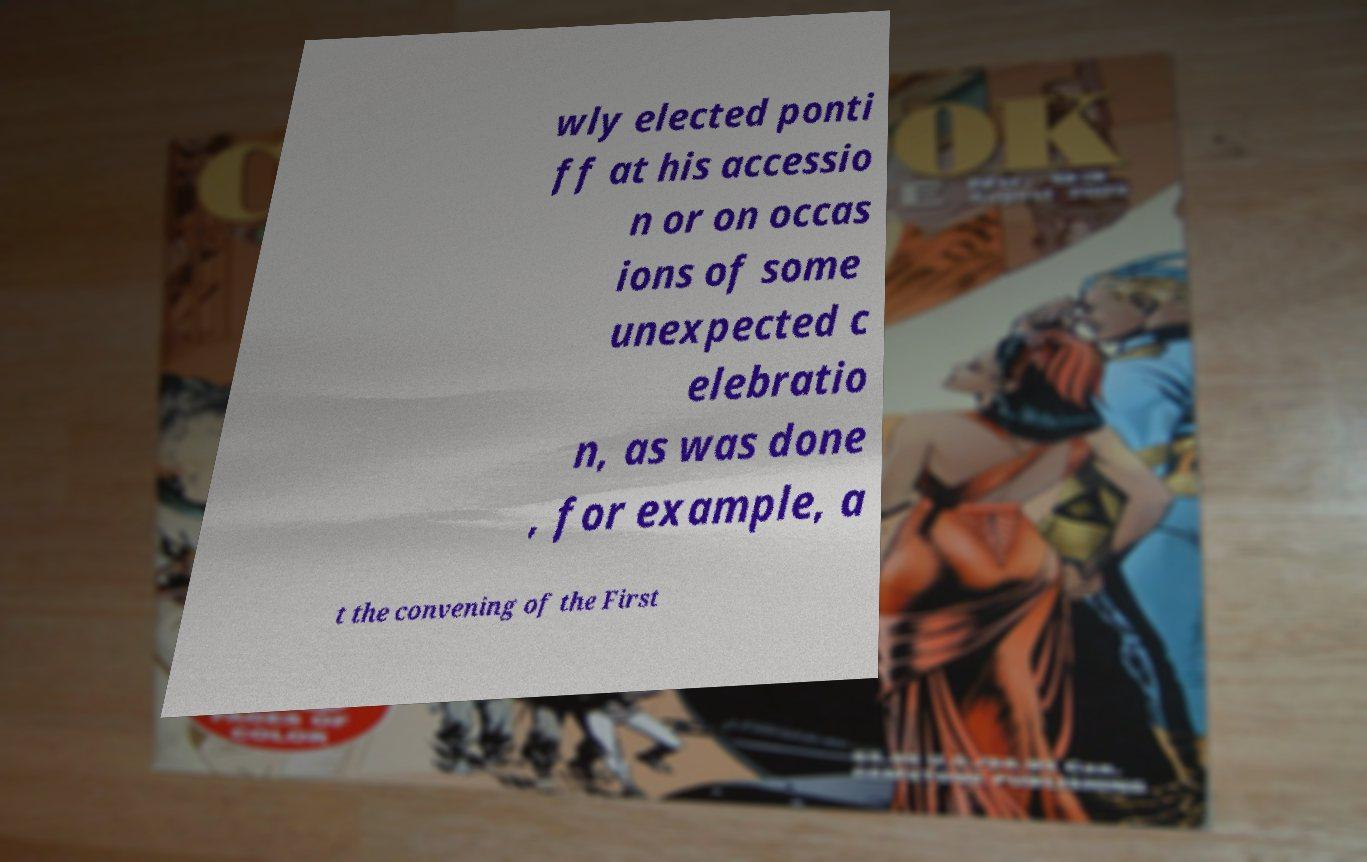Please read and relay the text visible in this image. What does it say? wly elected ponti ff at his accessio n or on occas ions of some unexpected c elebratio n, as was done , for example, a t the convening of the First 